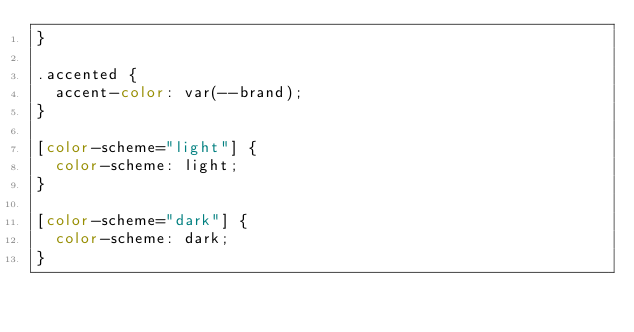<code> <loc_0><loc_0><loc_500><loc_500><_CSS_>}

.accented {
  accent-color: var(--brand);
}

[color-scheme="light"] {
  color-scheme: light;
}

[color-scheme="dark"] {
  color-scheme: dark;
}</code> 